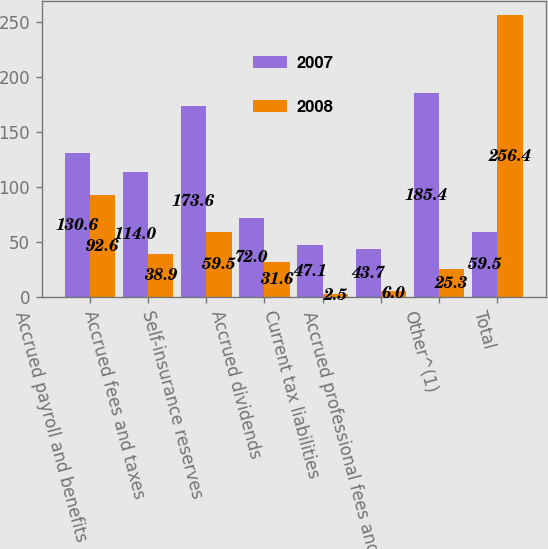Convert chart. <chart><loc_0><loc_0><loc_500><loc_500><stacked_bar_chart><ecel><fcel>Accrued payroll and benefits<fcel>Accrued fees and taxes<fcel>Self-insurance reserves<fcel>Accrued dividends<fcel>Current tax liabilities<fcel>Accrued professional fees and<fcel>Other^(1)<fcel>Total<nl><fcel>2007<fcel>130.6<fcel>114<fcel>173.6<fcel>72<fcel>47.1<fcel>43.7<fcel>185.4<fcel>59.5<nl><fcel>2008<fcel>92.6<fcel>38.9<fcel>59.5<fcel>31.6<fcel>2.5<fcel>6<fcel>25.3<fcel>256.4<nl></chart> 